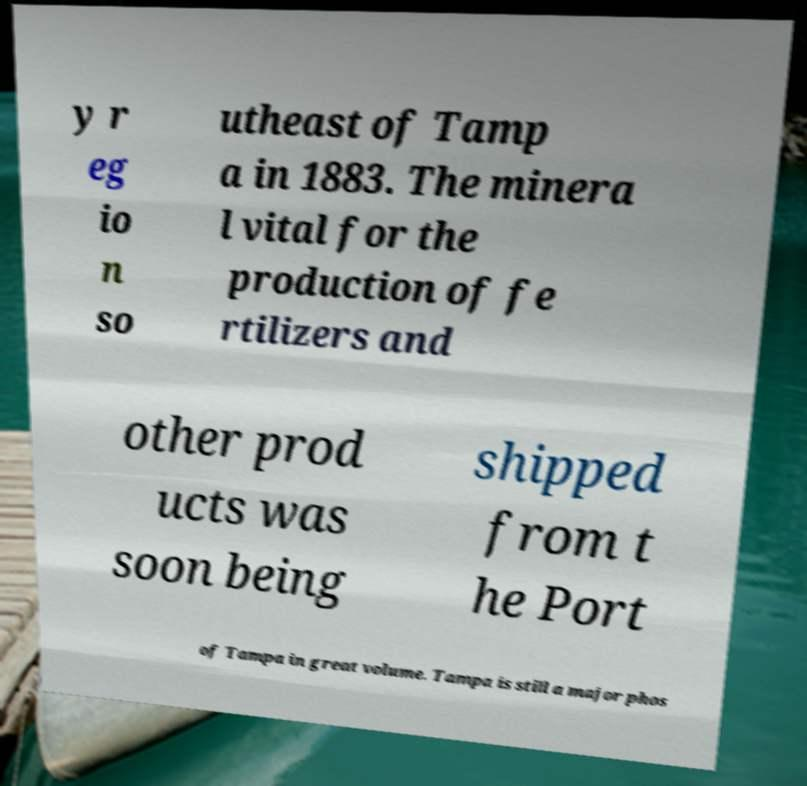Can you read and provide the text displayed in the image?This photo seems to have some interesting text. Can you extract and type it out for me? y r eg io n so utheast of Tamp a in 1883. The minera l vital for the production of fe rtilizers and other prod ucts was soon being shipped from t he Port of Tampa in great volume. Tampa is still a major phos 